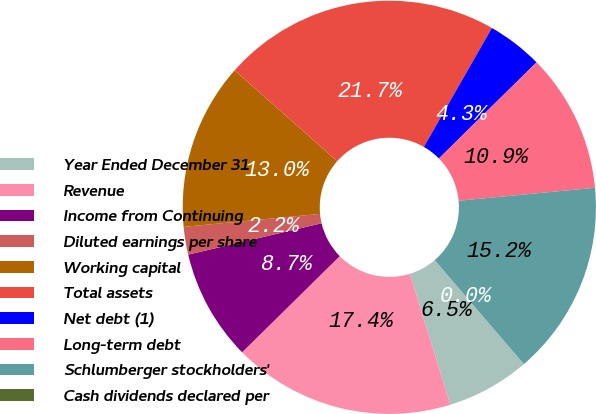<chart> <loc_0><loc_0><loc_500><loc_500><pie_chart><fcel>Year Ended December 31<fcel>Revenue<fcel>Income from Continuing<fcel>Diluted earnings per share<fcel>Working capital<fcel>Total assets<fcel>Net debt (1)<fcel>Long-term debt<fcel>Schlumberger stockholders'<fcel>Cash dividends declared per<nl><fcel>6.52%<fcel>17.39%<fcel>8.7%<fcel>2.17%<fcel>13.04%<fcel>21.74%<fcel>4.35%<fcel>10.87%<fcel>15.22%<fcel>0.0%<nl></chart> 